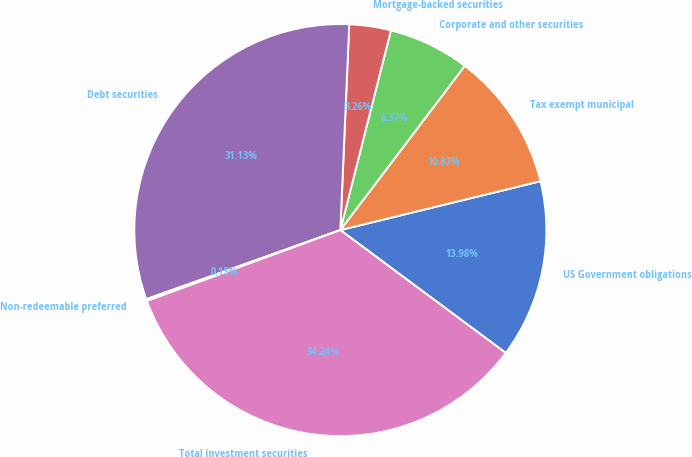<chart> <loc_0><loc_0><loc_500><loc_500><pie_chart><fcel>US Government obligations<fcel>Tax exempt municipal<fcel>Corporate and other securities<fcel>Mortgage-backed securities<fcel>Debt securities<fcel>Non-redeemable preferred<fcel>Total investment securities<nl><fcel>13.98%<fcel>10.87%<fcel>6.37%<fcel>3.26%<fcel>31.13%<fcel>0.15%<fcel>34.24%<nl></chart> 